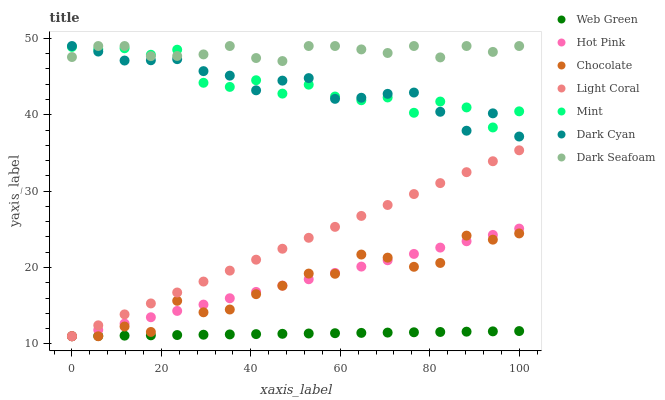Does Web Green have the minimum area under the curve?
Answer yes or no. Yes. Does Dark Seafoam have the maximum area under the curve?
Answer yes or no. Yes. Does Chocolate have the minimum area under the curve?
Answer yes or no. No. Does Chocolate have the maximum area under the curve?
Answer yes or no. No. Is Light Coral the smoothest?
Answer yes or no. Yes. Is Mint the roughest?
Answer yes or no. Yes. Is Web Green the smoothest?
Answer yes or no. No. Is Web Green the roughest?
Answer yes or no. No. Does Hot Pink have the lowest value?
Answer yes or no. Yes. Does Dark Seafoam have the lowest value?
Answer yes or no. No. Does Dark Cyan have the highest value?
Answer yes or no. Yes. Does Chocolate have the highest value?
Answer yes or no. No. Is Hot Pink less than Mint?
Answer yes or no. Yes. Is Dark Seafoam greater than Chocolate?
Answer yes or no. Yes. Does Hot Pink intersect Chocolate?
Answer yes or no. Yes. Is Hot Pink less than Chocolate?
Answer yes or no. No. Is Hot Pink greater than Chocolate?
Answer yes or no. No. Does Hot Pink intersect Mint?
Answer yes or no. No. 